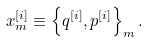Convert formula to latex. <formula><loc_0><loc_0><loc_500><loc_500>x _ { m } ^ { [ i ] } \equiv \left \{ q ^ { [ i ] } , p ^ { [ i ] } \right \} _ { m } .</formula> 